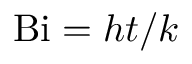Convert formula to latex. <formula><loc_0><loc_0><loc_500><loc_500>B i = h t / k</formula> 